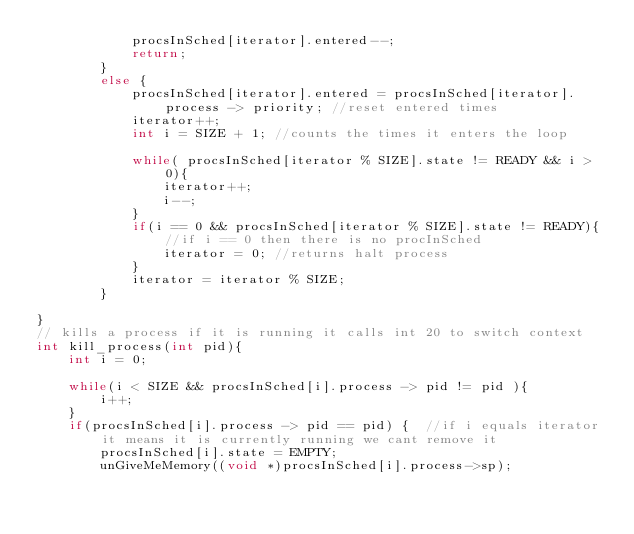<code> <loc_0><loc_0><loc_500><loc_500><_C_>            procsInSched[iterator].entered--;
            return;
        }
        else {    
            procsInSched[iterator].entered = procsInSched[iterator].process -> priority; //reset entered times
            iterator++;
            int i = SIZE + 1; //counts the times it enters the loop
        
            while( procsInSched[iterator % SIZE].state != READY && i > 0){
                iterator++;
                i--;
            }
            if(i == 0 && procsInSched[iterator % SIZE].state != READY){ //if i == 0 then there is no procInSched
                iterator = 0; //returns halt process
            }
            iterator = iterator % SIZE;
        }

}
// kills a process if it is running it calls int 20 to switch context
int kill_process(int pid){
    int i = 0;

    while(i < SIZE && procsInSched[i].process -> pid != pid ){
        i++;
    }
    if(procsInSched[i].process -> pid == pid) {  //if i equals iterator it means it is currently running we cant remove it
        procsInSched[i].state = EMPTY;
        unGiveMeMemory((void *)procsInSched[i].process->sp);</code> 